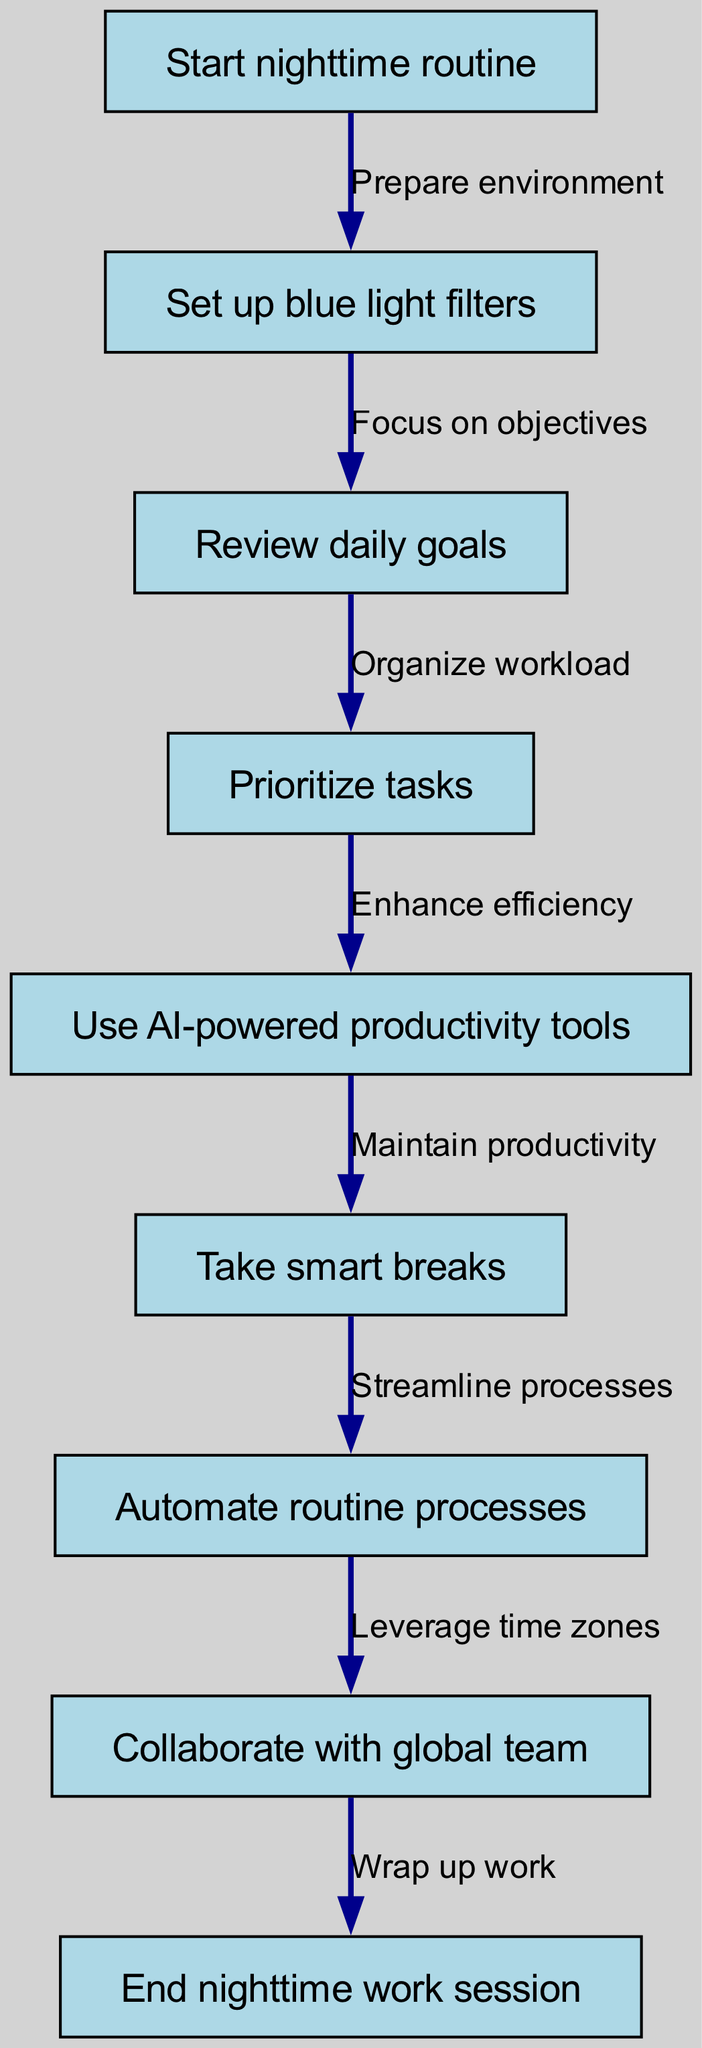What's the first step in the nighttime routine? The first node in the diagram is labeled "Start nighttime routine," indicating that this is the initial action.
Answer: Start nighttime routine How many nodes are in the diagram? The diagram lists a total of 9 nodes representing different steps in the nighttime work optimization routine.
Answer: 9 What action follows reviewing daily goals? The flow indicates that after "Review daily goals," the next step is "Prioritize tasks," which is directly connected by an edge.
Answer: Prioritize tasks Which node is connected to the "Collaborate with global team"? "Collaborate with global team" is linked by an edge from "Automate routine processes," signifying that it follows this step in the flow.
Answer: Automate routine processes What is the main purpose of using AI-powered productivity tools? The diagram shows that using AI-powered productivity tools aims to "Enhance efficiency," thus connecting improvements in productivity with the use of technology.
Answer: Enhance efficiency Which two nodes are directly connected by the "Focus on objectives" edge? The edge labeled "Focus on objectives" connects the nodes "Set up blue light filters" to "Review daily goals," illustrating the sequence of steps.
Answer: Set up blue light filters, Review daily goals What is the last step in the nighttime work routine? The final action in the flow chart is labeled "End nighttime work session," indicating this is the conclusion of the nighttime routine.
Answer: End nighttime work session How does "Take smart breaks" contribute to nighttime work optimization? "Take smart breaks" is associated with maintaining productivity, showing its role in helping sustain focus and output during the nighttime routine.
Answer: Maintain productivity 